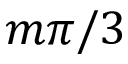Convert formula to latex. <formula><loc_0><loc_0><loc_500><loc_500>m \pi / 3</formula> 